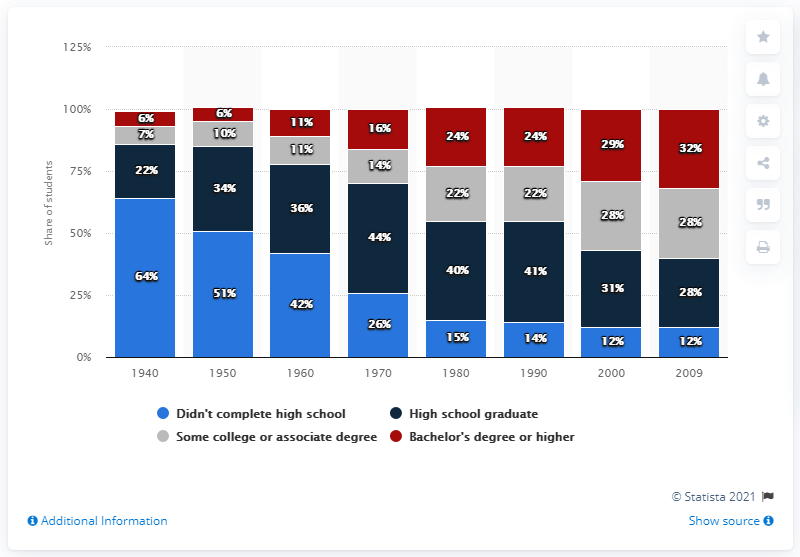List a handful of essential elements in this visual. In 2009, it was estimated that approximately 12% of the population did not complete their high school education. 